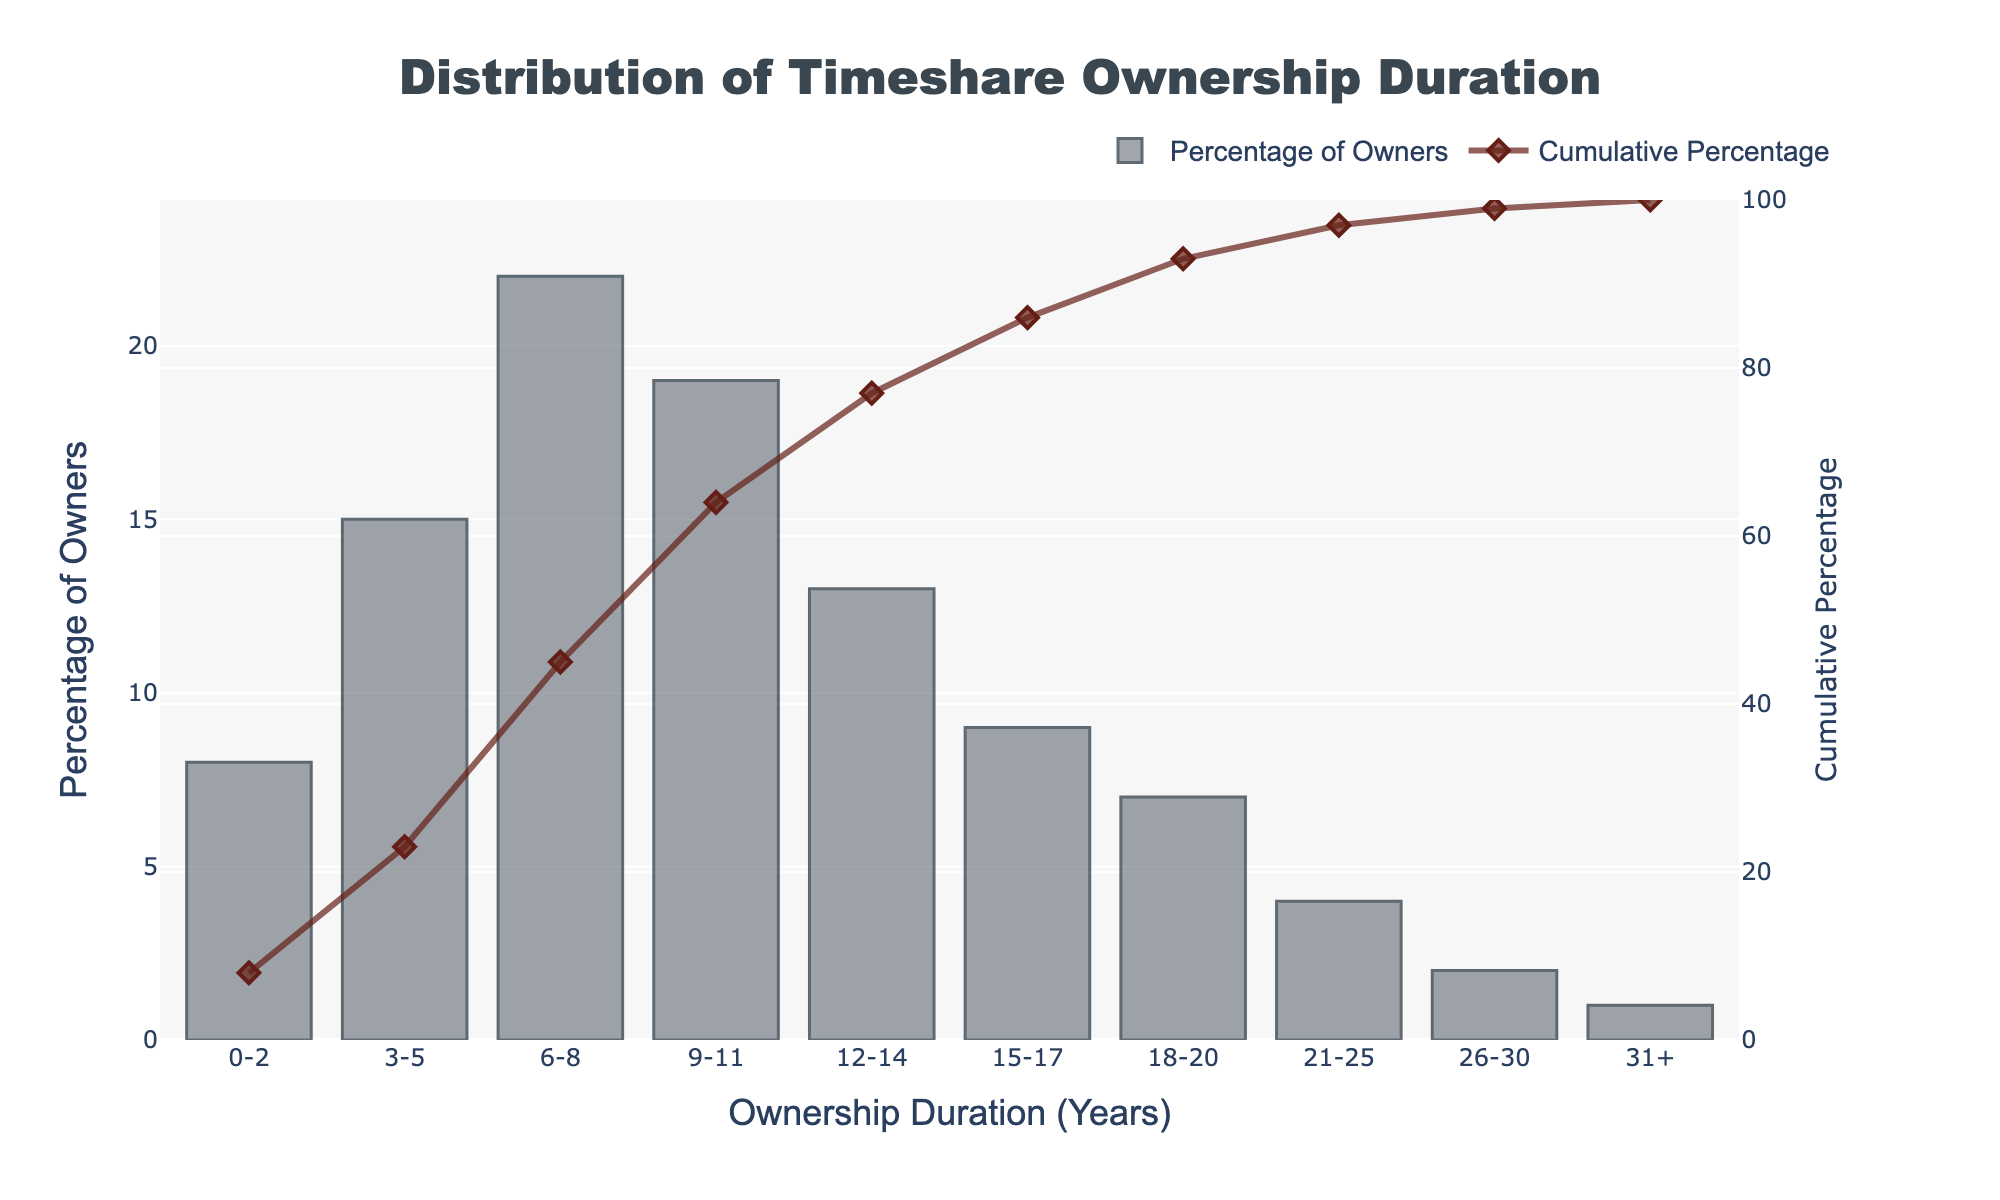How many owners have timeshare ownership durations of 3-5 years compared to 9-11 years? The percentage of owners with durations of 3-5 years is 15%, while it is 19% for 9-11 years. A comparison shows that 19% is greater than 15%.
Answer: 19% is greater than 15% What is the cumulative percentage of owners for durations up to 8 years? The cumulative percentage can be found by summing the percentages for the durations of 0-2, 3-5, and 6-8 years. This is 8% + 15% + 22% = 45%.
Answer: 45% Which ownership duration category has the highest percentage of owners? By observing the heights of the bars, the category 6-8 years has the highest bar, representing 22%.
Answer: 6-8 years How does the cumulative percentage change from the 15-17 years category to the 18-20 years category? From the figure, the cumulative percentage at 15-17 years is 86% and at 18-20 years is 93%. The change is 93% - 86% = 7%.
Answer: 7% What percentage of owners have ownership durations longer than 20 years? The categories representing ownership durations longer than 20 years are 21-25, 26-30, and 31+. The percentages are 4%, 2%, and 1% respectively. Summing these gives 4% + 2% + 1% = 7%.
Answer: 7% Between which two adjacent ownership duration categories is the largest drop in the percentage of owners? The analysis shows the percentages of owners are: 22% (6-8), 19% (9-11), and 13% (12-14) respectively. The drop from 9-11 to 12-14 years is the largest, which is 19% - 13% = 6%.
Answer: 9-11 to 12-14 years What is the average percentage of owners for the duration categories of 12-14 years and 15-17 years? The percentages for the categories 12-14 years and 15-17 years are 13% and 9% respectively. The average is (13% + 9%) / 2 = 11%.
Answer: 11% What is the overall trend in the cumulative percentage as the ownership duration increases? The cumulative percentage consistently increases as ownership duration increases, reaching closer to 100%. This indicates that cumulative percentage is effectively capturing the cumulative share of owners.
Answer: Increasing trend 